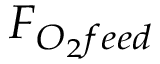Convert formula to latex. <formula><loc_0><loc_0><loc_500><loc_500>F _ { O _ { 2 } f e e d }</formula> 